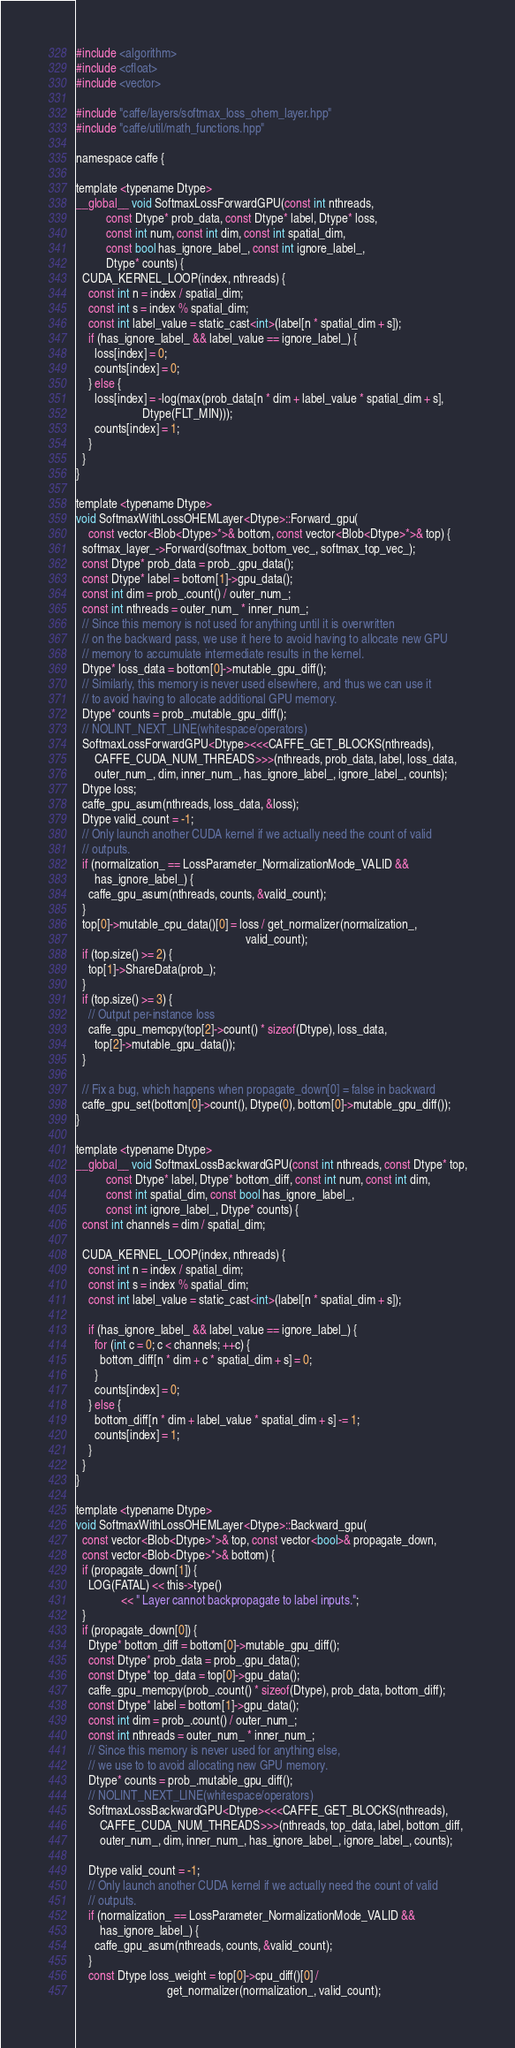Convert code to text. <code><loc_0><loc_0><loc_500><loc_500><_Cuda_>#include <algorithm>
#include <cfloat>
#include <vector>

#include "caffe/layers/softmax_loss_ohem_layer.hpp"
#include "caffe/util/math_functions.hpp"

namespace caffe {

template <typename Dtype>
__global__ void SoftmaxLossForwardGPU(const int nthreads,
          const Dtype* prob_data, const Dtype* label, Dtype* loss,
          const int num, const int dim, const int spatial_dim,
          const bool has_ignore_label_, const int ignore_label_,
          Dtype* counts) {
  CUDA_KERNEL_LOOP(index, nthreads) {
    const int n = index / spatial_dim;
    const int s = index % spatial_dim;
    const int label_value = static_cast<int>(label[n * spatial_dim + s]);
    if (has_ignore_label_ && label_value == ignore_label_) {
      loss[index] = 0;
      counts[index] = 0;
    } else {
      loss[index] = -log(max(prob_data[n * dim + label_value * spatial_dim + s],
                      Dtype(FLT_MIN)));
      counts[index] = 1;
    }
  }
}

template <typename Dtype>
void SoftmaxWithLossOHEMLayer<Dtype>::Forward_gpu(
    const vector<Blob<Dtype>*>& bottom, const vector<Blob<Dtype>*>& top) {
  softmax_layer_->Forward(softmax_bottom_vec_, softmax_top_vec_);
  const Dtype* prob_data = prob_.gpu_data();
  const Dtype* label = bottom[1]->gpu_data();
  const int dim = prob_.count() / outer_num_;
  const int nthreads = outer_num_ * inner_num_;
  // Since this memory is not used for anything until it is overwritten
  // on the backward pass, we use it here to avoid having to allocate new GPU
  // memory to accumulate intermediate results in the kernel.
  Dtype* loss_data = bottom[0]->mutable_gpu_diff();
  // Similarly, this memory is never used elsewhere, and thus we can use it
  // to avoid having to allocate additional GPU memory.
  Dtype* counts = prob_.mutable_gpu_diff();
  // NOLINT_NEXT_LINE(whitespace/operators)
  SoftmaxLossForwardGPU<Dtype><<<CAFFE_GET_BLOCKS(nthreads),
      CAFFE_CUDA_NUM_THREADS>>>(nthreads, prob_data, label, loss_data,
      outer_num_, dim, inner_num_, has_ignore_label_, ignore_label_, counts);
  Dtype loss;
  caffe_gpu_asum(nthreads, loss_data, &loss);
  Dtype valid_count = -1;
  // Only launch another CUDA kernel if we actually need the count of valid
  // outputs.
  if (normalization_ == LossParameter_NormalizationMode_VALID &&
      has_ignore_label_) {
    caffe_gpu_asum(nthreads, counts, &valid_count);
  }
  top[0]->mutable_cpu_data()[0] = loss / get_normalizer(normalization_,
                                                        valid_count);
  if (top.size() >= 2) {
    top[1]->ShareData(prob_);
  }
  if (top.size() >= 3) {
    // Output per-instance loss
    caffe_gpu_memcpy(top[2]->count() * sizeof(Dtype), loss_data,
      top[2]->mutable_gpu_data());
  }

  // Fix a bug, which happens when propagate_down[0] = false in backward
  caffe_gpu_set(bottom[0]->count(), Dtype(0), bottom[0]->mutable_gpu_diff());
}

template <typename Dtype>
__global__ void SoftmaxLossBackwardGPU(const int nthreads, const Dtype* top,
          const Dtype* label, Dtype* bottom_diff, const int num, const int dim,
          const int spatial_dim, const bool has_ignore_label_,
          const int ignore_label_, Dtype* counts) {
  const int channels = dim / spatial_dim;

  CUDA_KERNEL_LOOP(index, nthreads) {
    const int n = index / spatial_dim;
    const int s = index % spatial_dim;
    const int label_value = static_cast<int>(label[n * spatial_dim + s]);

    if (has_ignore_label_ && label_value == ignore_label_) {
      for (int c = 0; c < channels; ++c) {
        bottom_diff[n * dim + c * spatial_dim + s] = 0;
      }
      counts[index] = 0;
    } else {
      bottom_diff[n * dim + label_value * spatial_dim + s] -= 1;
      counts[index] = 1;
    }
  }
}

template <typename Dtype>
void SoftmaxWithLossOHEMLayer<Dtype>::Backward_gpu(
  const vector<Blob<Dtype>*>& top, const vector<bool>& propagate_down,
  const vector<Blob<Dtype>*>& bottom) {
  if (propagate_down[1]) {
    LOG(FATAL) << this->type()
               << " Layer cannot backpropagate to label inputs.";
  }
  if (propagate_down[0]) {
    Dtype* bottom_diff = bottom[0]->mutable_gpu_diff();
    const Dtype* prob_data = prob_.gpu_data();
    const Dtype* top_data = top[0]->gpu_data();
    caffe_gpu_memcpy(prob_.count() * sizeof(Dtype), prob_data, bottom_diff);
    const Dtype* label = bottom[1]->gpu_data();
    const int dim = prob_.count() / outer_num_;
    const int nthreads = outer_num_ * inner_num_;
    // Since this memory is never used for anything else,
    // we use to to avoid allocating new GPU memory.
    Dtype* counts = prob_.mutable_gpu_diff();
    // NOLINT_NEXT_LINE(whitespace/operators)
    SoftmaxLossBackwardGPU<Dtype><<<CAFFE_GET_BLOCKS(nthreads),
        CAFFE_CUDA_NUM_THREADS>>>(nthreads, top_data, label, bottom_diff,
        outer_num_, dim, inner_num_, has_ignore_label_, ignore_label_, counts);

    Dtype valid_count = -1;
    // Only launch another CUDA kernel if we actually need the count of valid
    // outputs.
    if (normalization_ == LossParameter_NormalizationMode_VALID &&
        has_ignore_label_) {
      caffe_gpu_asum(nthreads, counts, &valid_count);
    }
    const Dtype loss_weight = top[0]->cpu_diff()[0] /
                              get_normalizer(normalization_, valid_count);</code> 